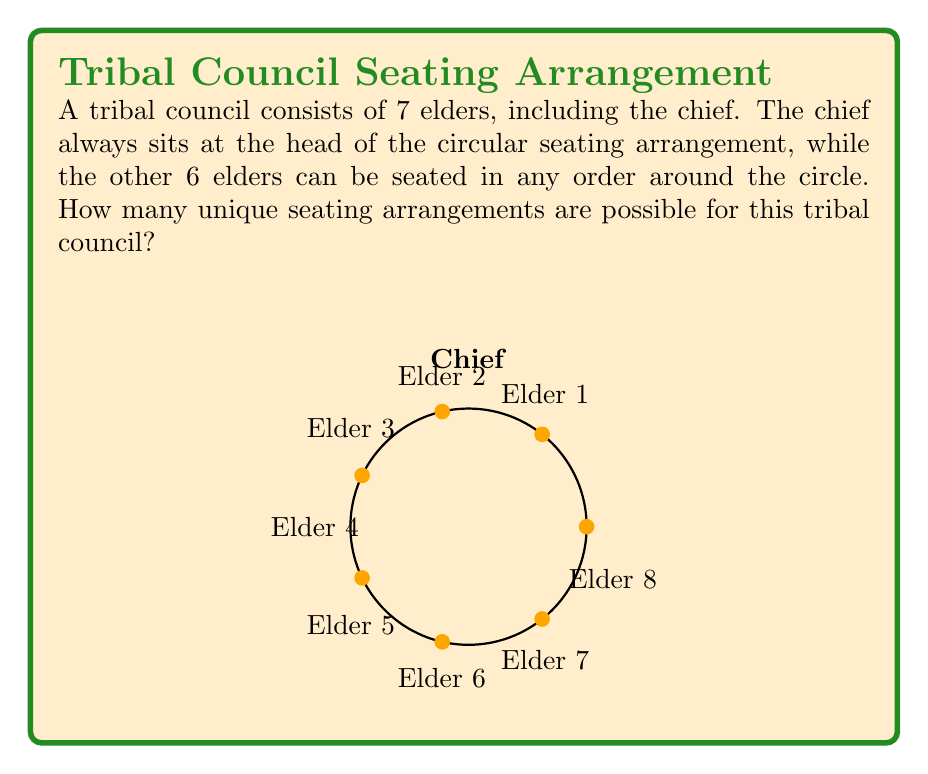Provide a solution to this math problem. To solve this problem, we need to consider the following steps:

1) The chief's position is fixed, so we only need to arrange the other 6 elders.

2) This is a circular permutation problem. In a circular arrangement, rotations of the same arrangement are considered identical. For example, the arrangements (1,2,3,4,5,6) and (2,3,4,5,6,1) are considered the same in a circular arrangement.

3) The formula for circular permutations of $n$ distinct objects is:

   $$(n-1)!$$

4) In this case, $n = 6$ (the number of elders excluding the chief).

5) Therefore, the number of unique seating arrangements is:

   $$(6-1)! = 5! = 5 \times 4 \times 3 \times 2 \times 1 = 120$$

Thus, there are 120 possible unique seating arrangements for the tribal council.
Answer: 120 